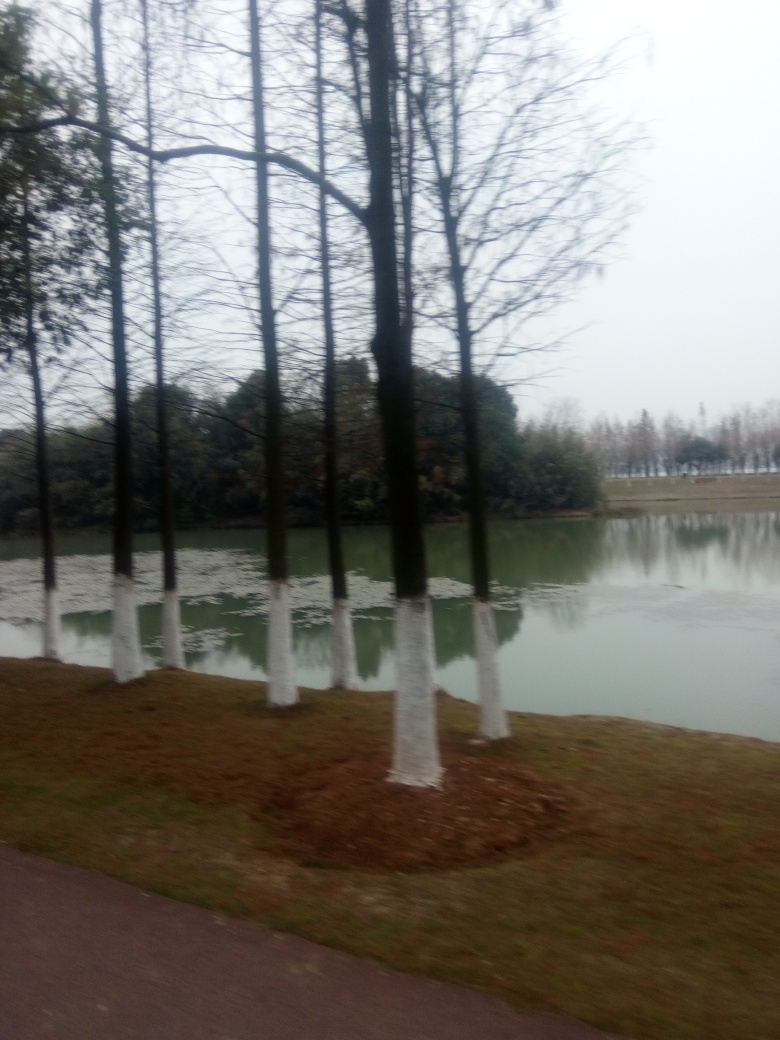Can the texture of the ground be clearly seen?
A. No
B. Yes
Answer with the option's letter from the given choices directly.
 A. 